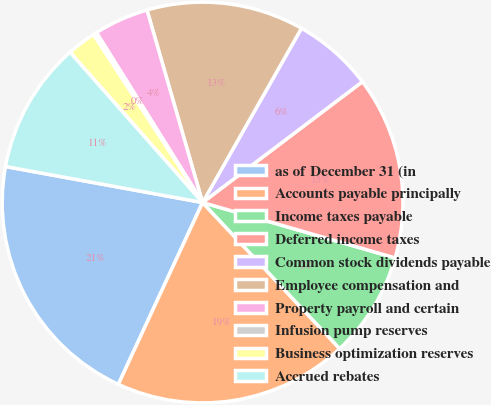<chart> <loc_0><loc_0><loc_500><loc_500><pie_chart><fcel>as of December 31 (in<fcel>Accounts payable principally<fcel>Income taxes payable<fcel>Deferred income taxes<fcel>Common stock dividends payable<fcel>Employee compensation and<fcel>Property payroll and certain<fcel>Infusion pump reserves<fcel>Business optimization reserves<fcel>Accrued rebates<nl><fcel>20.97%<fcel>18.9%<fcel>8.55%<fcel>14.76%<fcel>6.48%<fcel>12.69%<fcel>4.41%<fcel>0.28%<fcel>2.34%<fcel>10.62%<nl></chart> 